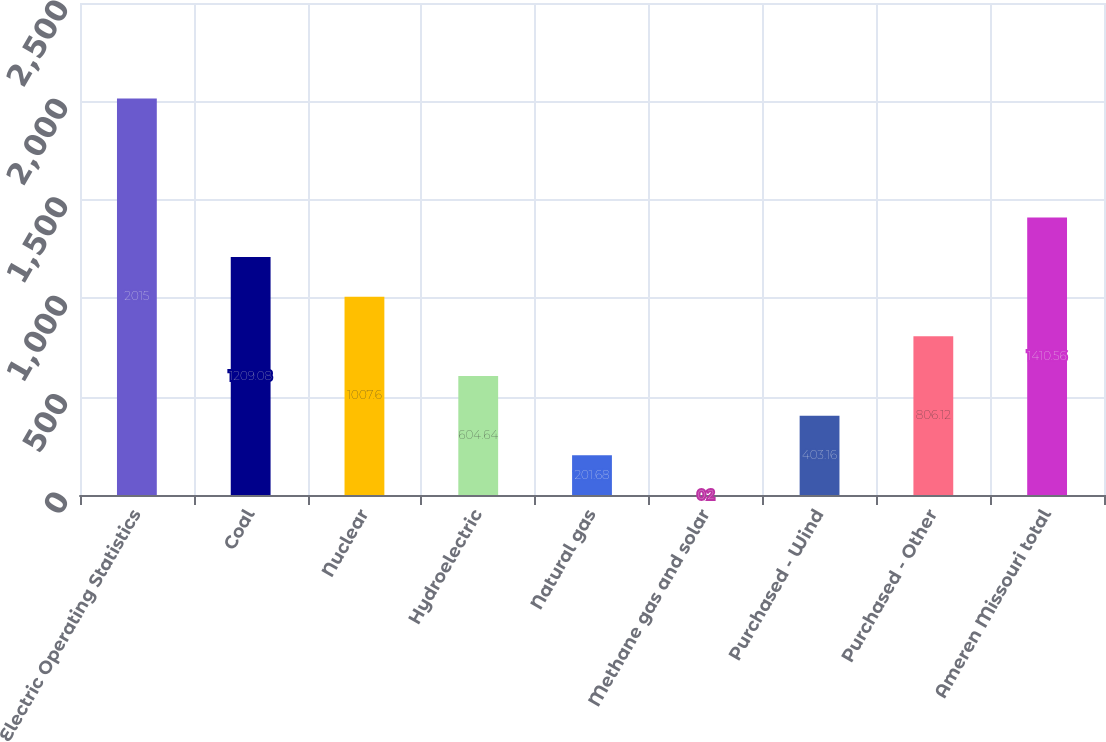<chart> <loc_0><loc_0><loc_500><loc_500><bar_chart><fcel>Electric Operating Statistics<fcel>Coal<fcel>Nuclear<fcel>Hydroelectric<fcel>Natural gas<fcel>Methane gas and solar<fcel>Purchased - Wind<fcel>Purchased - Other<fcel>Ameren Missouri total<nl><fcel>2015<fcel>1209.08<fcel>1007.6<fcel>604.64<fcel>201.68<fcel>0.2<fcel>403.16<fcel>806.12<fcel>1410.56<nl></chart> 